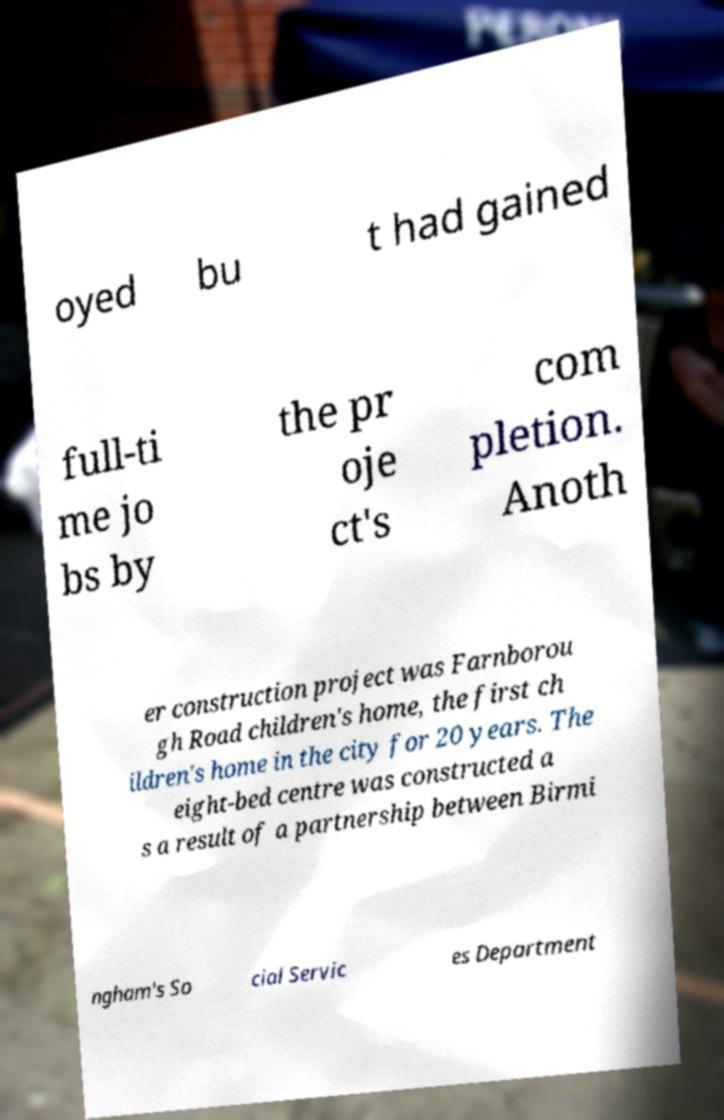Could you assist in decoding the text presented in this image and type it out clearly? oyed bu t had gained full-ti me jo bs by the pr oje ct's com pletion. Anoth er construction project was Farnborou gh Road children's home, the first ch ildren's home in the city for 20 years. The eight-bed centre was constructed a s a result of a partnership between Birmi ngham's So cial Servic es Department 